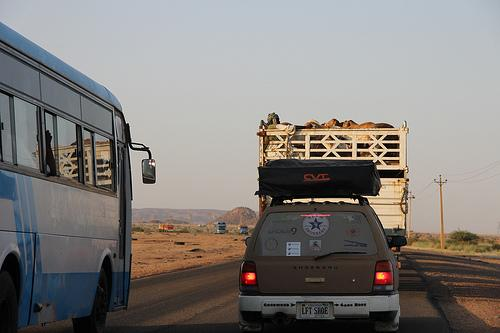Describe the primary colors and the objects they belong to in the image. Predominant colors in the image include blue (sky, bus), white (license plates), red (brake lights, tail lights), green (bush, grass), and black (power lines, bag). Write a poetic description of the scenery depicted in the image. A caravan meanders down the open road, blue sky shining above, while metal behemoths of transport - bus, car, and truck - share tales of the street, illuminated by red lights and bearing the mark of the license plate. Describe the miscellaneous objects found in the image. Various objects in the image include a green bush, patches of grass, a tall power pole, long black power lines, and a clear blue sky. Describe the location where the image was taken. The image seems to be taken on a highway with multiple lanes, where various vehicles like a bus, a car, and a truck are traveling under a clear blue sky. Comment on the weather and road conditions in the image. The weather in the image appears to be clear, with a blue sky, and the road conditions seem to be good for driving. Write a brief summary of the significant elements in the image. The image shows vehicles like a bus, a car, and a truck on the road, with multiple windows, license plates, headlights, and taillights. The sky is blue, and there's a power pole and power lines. Mention the unique features of each vehicle in the image. The bus has multiple windows and a rear-view mirror, the car carries a large black bag on its roof, and the truck is loaded with animals and has a star on its back. Imagine being in one of the vehicles and describe what you see from your perspective. From inside the sedan, I see the long blue and white bus on my left, the sky is clear blue, and up ahead is a white truck carrying animals. Red taillights flicker, reminding me to maintain a safe distance. Mention the types of vehicles and their distinguishing features visible in the image. The image features a long blue and white bus with several windows and rear-view mirror, a sedan carrying a large black bag on its roof, and a truck carrying lots of animals. Describe the environment surrounding the vehicles in the image. The vehicles are surrounded by a clear blue sky, a green bush, patches of grass, a tall power pole, and long black power lines. 